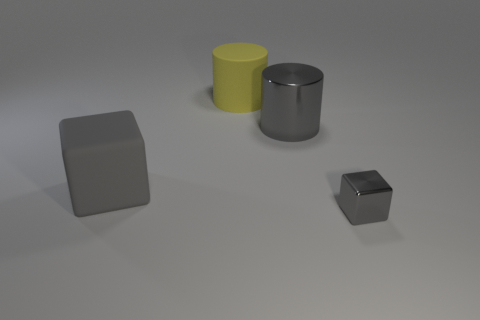Add 3 yellow cylinders. How many objects exist? 7 Subtract 0 yellow blocks. How many objects are left? 4 Subtract all brown matte balls. Subtract all metallic blocks. How many objects are left? 3 Add 4 cylinders. How many cylinders are left? 6 Add 3 cylinders. How many cylinders exist? 5 